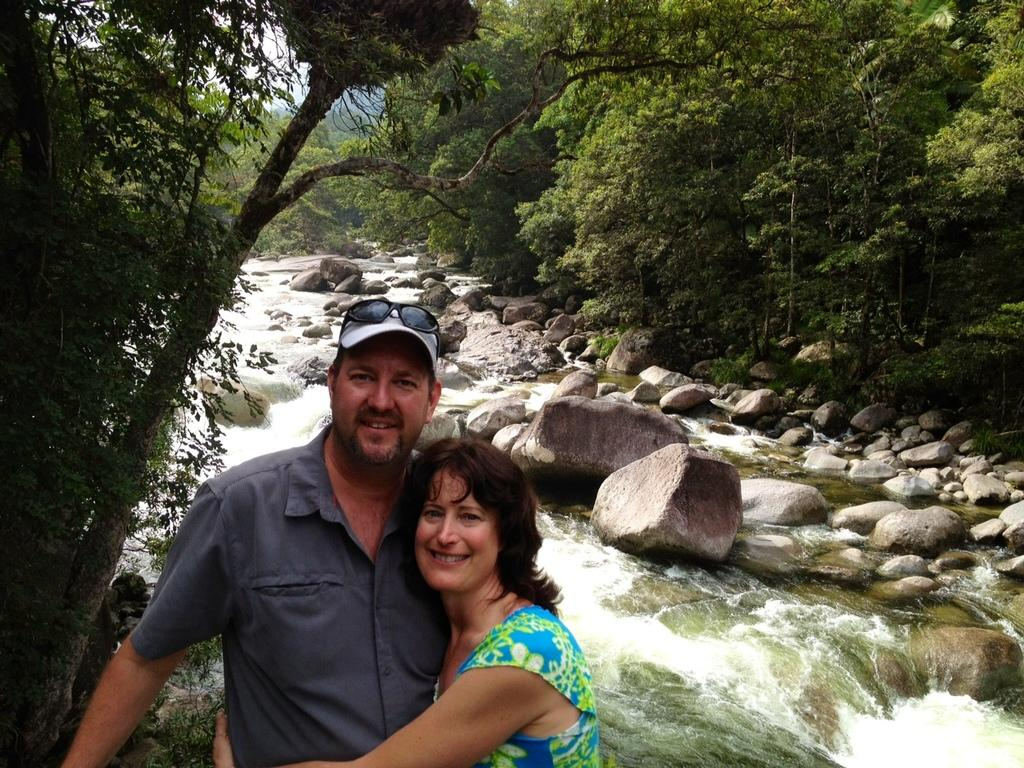How many persons are present in the image? There are two persons in the image. What are the persons wearing? The persons are wearing clothes. What type of natural feature can be seen in the image? There is a canal visible in the image. What type of vegetation is present in the image? There are trees in the image. What type of paste is being used by the persons in the image? There is no indication in the image that any paste is being used by the persons. How many nets are visible in the image? There are no nets present in the image. 